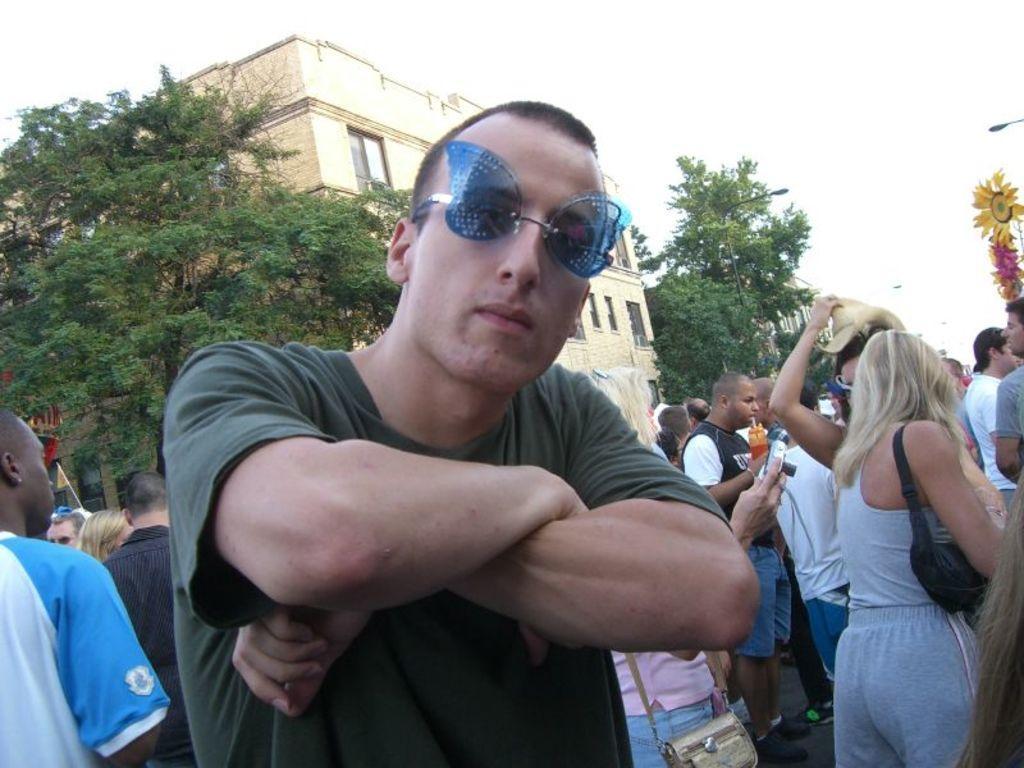Could you give a brief overview of what you see in this image? In front of the image there is a person, behind the person there are a few people, behind them there are lamp posts, trees and buildings. On the right side of the image there is some object. 